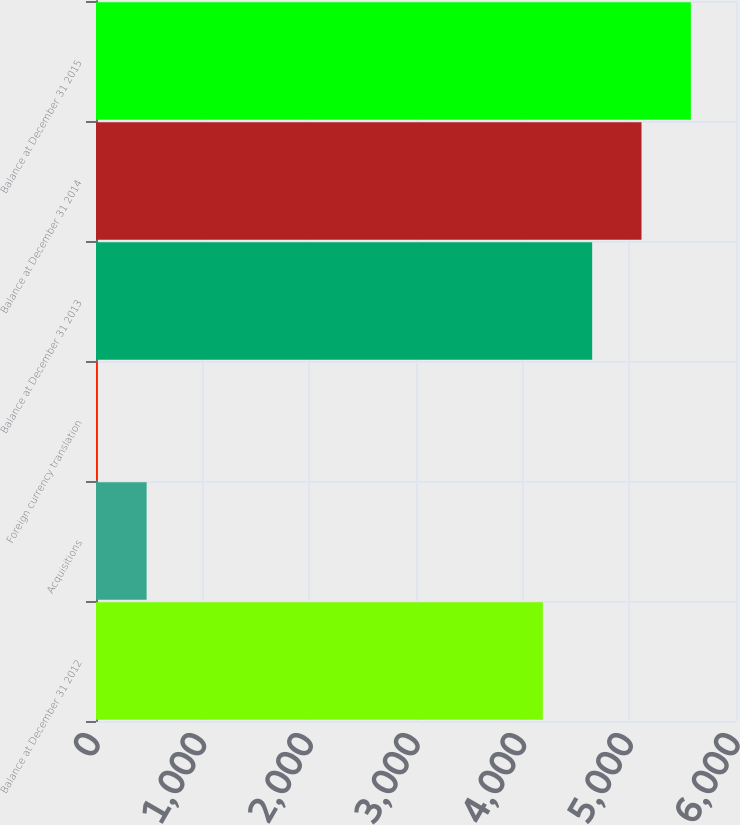Convert chart. <chart><loc_0><loc_0><loc_500><loc_500><bar_chart><fcel>Balance at December 31 2012<fcel>Acquisitions<fcel>Foreign currency translation<fcel>Balance at December 31 2013<fcel>Balance at December 31 2014<fcel>Balance at December 31 2015<nl><fcel>4189<fcel>474.6<fcel>12<fcel>4651.6<fcel>5114.2<fcel>5576.8<nl></chart> 